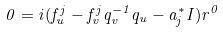Convert formula to latex. <formula><loc_0><loc_0><loc_500><loc_500>0 = i ( f ^ { j } _ { u } - f ^ { j } _ { v } q _ { v } ^ { - 1 } q _ { u } - a _ { j } ^ { * } I ) r ^ { 0 }</formula> 